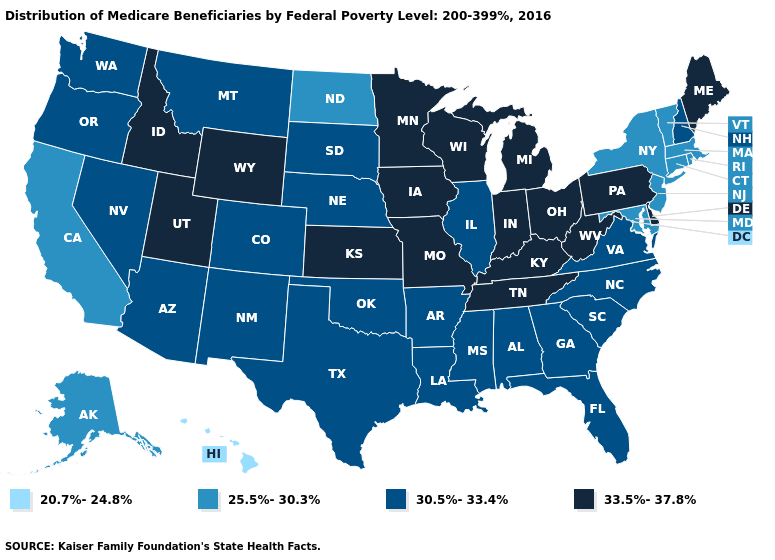Name the states that have a value in the range 20.7%-24.8%?
Keep it brief. Hawaii. What is the value of Rhode Island?
Answer briefly. 25.5%-30.3%. Does the first symbol in the legend represent the smallest category?
Short answer required. Yes. What is the value of Massachusetts?
Quick response, please. 25.5%-30.3%. Does Arizona have a lower value than Ohio?
Quick response, please. Yes. Does the map have missing data?
Concise answer only. No. What is the lowest value in the Northeast?
Concise answer only. 25.5%-30.3%. What is the highest value in the South ?
Short answer required. 33.5%-37.8%. Does Florida have the highest value in the USA?
Give a very brief answer. No. Does Maryland have the lowest value in the South?
Give a very brief answer. Yes. Which states hav the highest value in the MidWest?
Quick response, please. Indiana, Iowa, Kansas, Michigan, Minnesota, Missouri, Ohio, Wisconsin. Does Oklahoma have the lowest value in the USA?
Keep it brief. No. What is the lowest value in states that border Kentucky?
Concise answer only. 30.5%-33.4%. Does Oklahoma have the highest value in the South?
Short answer required. No. What is the value of Nevada?
Give a very brief answer. 30.5%-33.4%. 